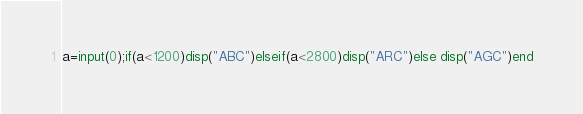<code> <loc_0><loc_0><loc_500><loc_500><_Octave_>a=input(0);if(a<1200)disp("ABC")elseif(a<2800)disp("ARC")else disp("AGC")end</code> 